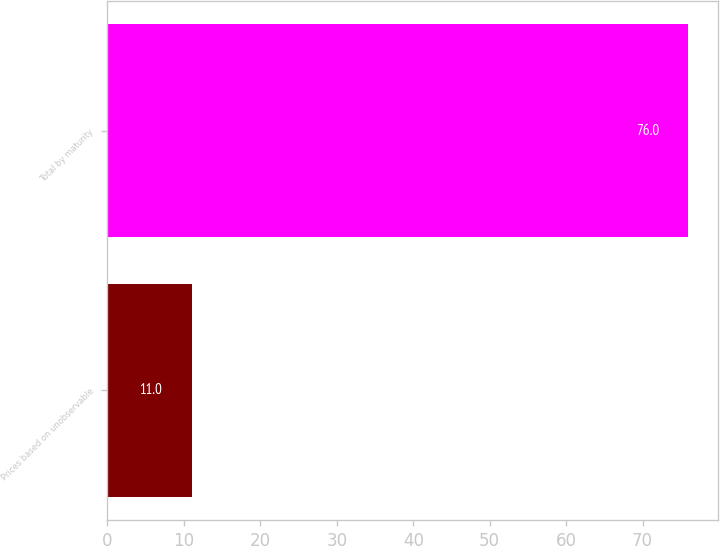Convert chart to OTSL. <chart><loc_0><loc_0><loc_500><loc_500><bar_chart><fcel>Prices based on unobservable<fcel>Total by maturity<nl><fcel>11<fcel>76<nl></chart> 